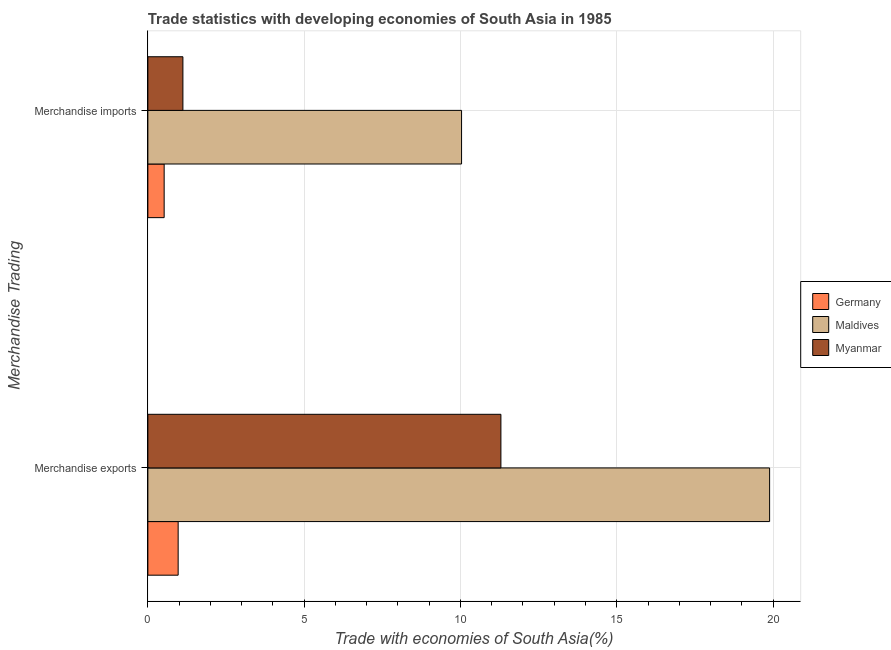How many different coloured bars are there?
Your response must be concise. 3. Are the number of bars per tick equal to the number of legend labels?
Offer a terse response. Yes. Are the number of bars on each tick of the Y-axis equal?
Provide a succinct answer. Yes. How many bars are there on the 1st tick from the top?
Give a very brief answer. 3. What is the merchandise exports in Myanmar?
Give a very brief answer. 11.29. Across all countries, what is the maximum merchandise exports?
Ensure brevity in your answer.  19.89. Across all countries, what is the minimum merchandise imports?
Provide a short and direct response. 0.52. In which country was the merchandise exports maximum?
Make the answer very short. Maldives. What is the total merchandise exports in the graph?
Ensure brevity in your answer.  32.15. What is the difference between the merchandise imports in Myanmar and that in Maldives?
Offer a very short reply. -8.91. What is the difference between the merchandise imports in Germany and the merchandise exports in Maldives?
Offer a terse response. -19.37. What is the average merchandise exports per country?
Offer a very short reply. 10.72. What is the difference between the merchandise exports and merchandise imports in Myanmar?
Your answer should be very brief. 10.17. What is the ratio of the merchandise exports in Germany to that in Maldives?
Keep it short and to the point. 0.05. What does the 1st bar from the top in Merchandise exports represents?
Offer a very short reply. Myanmar. What does the 3rd bar from the bottom in Merchandise imports represents?
Keep it short and to the point. Myanmar. How many bars are there?
Offer a terse response. 6. What is the difference between two consecutive major ticks on the X-axis?
Provide a succinct answer. 5. What is the title of the graph?
Ensure brevity in your answer.  Trade statistics with developing economies of South Asia in 1985. Does "St. Kitts and Nevis" appear as one of the legend labels in the graph?
Make the answer very short. No. What is the label or title of the X-axis?
Offer a terse response. Trade with economies of South Asia(%). What is the label or title of the Y-axis?
Offer a terse response. Merchandise Trading. What is the Trade with economies of South Asia(%) of Germany in Merchandise exports?
Make the answer very short. 0.97. What is the Trade with economies of South Asia(%) in Maldives in Merchandise exports?
Provide a succinct answer. 19.89. What is the Trade with economies of South Asia(%) of Myanmar in Merchandise exports?
Your response must be concise. 11.29. What is the Trade with economies of South Asia(%) of Germany in Merchandise imports?
Offer a very short reply. 0.52. What is the Trade with economies of South Asia(%) of Maldives in Merchandise imports?
Offer a terse response. 10.04. What is the Trade with economies of South Asia(%) in Myanmar in Merchandise imports?
Your response must be concise. 1.12. Across all Merchandise Trading, what is the maximum Trade with economies of South Asia(%) in Germany?
Provide a short and direct response. 0.97. Across all Merchandise Trading, what is the maximum Trade with economies of South Asia(%) in Maldives?
Your answer should be compact. 19.89. Across all Merchandise Trading, what is the maximum Trade with economies of South Asia(%) of Myanmar?
Keep it short and to the point. 11.29. Across all Merchandise Trading, what is the minimum Trade with economies of South Asia(%) in Germany?
Ensure brevity in your answer.  0.52. Across all Merchandise Trading, what is the minimum Trade with economies of South Asia(%) of Maldives?
Give a very brief answer. 10.04. Across all Merchandise Trading, what is the minimum Trade with economies of South Asia(%) of Myanmar?
Your answer should be compact. 1.12. What is the total Trade with economies of South Asia(%) of Germany in the graph?
Keep it short and to the point. 1.49. What is the total Trade with economies of South Asia(%) of Maldives in the graph?
Your answer should be compact. 29.93. What is the total Trade with economies of South Asia(%) in Myanmar in the graph?
Your answer should be very brief. 12.41. What is the difference between the Trade with economies of South Asia(%) in Germany in Merchandise exports and that in Merchandise imports?
Your answer should be compact. 0.45. What is the difference between the Trade with economies of South Asia(%) of Maldives in Merchandise exports and that in Merchandise imports?
Give a very brief answer. 9.85. What is the difference between the Trade with economies of South Asia(%) of Myanmar in Merchandise exports and that in Merchandise imports?
Provide a short and direct response. 10.17. What is the difference between the Trade with economies of South Asia(%) of Germany in Merchandise exports and the Trade with economies of South Asia(%) of Maldives in Merchandise imports?
Give a very brief answer. -9.07. What is the difference between the Trade with economies of South Asia(%) in Germany in Merchandise exports and the Trade with economies of South Asia(%) in Myanmar in Merchandise imports?
Make the answer very short. -0.15. What is the difference between the Trade with economies of South Asia(%) in Maldives in Merchandise exports and the Trade with economies of South Asia(%) in Myanmar in Merchandise imports?
Provide a short and direct response. 18.77. What is the average Trade with economies of South Asia(%) of Germany per Merchandise Trading?
Your answer should be compact. 0.74. What is the average Trade with economies of South Asia(%) of Maldives per Merchandise Trading?
Your response must be concise. 14.96. What is the average Trade with economies of South Asia(%) of Myanmar per Merchandise Trading?
Provide a succinct answer. 6.21. What is the difference between the Trade with economies of South Asia(%) in Germany and Trade with economies of South Asia(%) in Maldives in Merchandise exports?
Your answer should be very brief. -18.92. What is the difference between the Trade with economies of South Asia(%) of Germany and Trade with economies of South Asia(%) of Myanmar in Merchandise exports?
Offer a very short reply. -10.32. What is the difference between the Trade with economies of South Asia(%) in Maldives and Trade with economies of South Asia(%) in Myanmar in Merchandise exports?
Your answer should be compact. 8.6. What is the difference between the Trade with economies of South Asia(%) of Germany and Trade with economies of South Asia(%) of Maldives in Merchandise imports?
Offer a very short reply. -9.51. What is the difference between the Trade with economies of South Asia(%) in Germany and Trade with economies of South Asia(%) in Myanmar in Merchandise imports?
Your answer should be compact. -0.6. What is the difference between the Trade with economies of South Asia(%) in Maldives and Trade with economies of South Asia(%) in Myanmar in Merchandise imports?
Ensure brevity in your answer.  8.91. What is the ratio of the Trade with economies of South Asia(%) of Germany in Merchandise exports to that in Merchandise imports?
Make the answer very short. 1.86. What is the ratio of the Trade with economies of South Asia(%) in Maldives in Merchandise exports to that in Merchandise imports?
Give a very brief answer. 1.98. What is the ratio of the Trade with economies of South Asia(%) in Myanmar in Merchandise exports to that in Merchandise imports?
Your answer should be very brief. 10.07. What is the difference between the highest and the second highest Trade with economies of South Asia(%) of Germany?
Your response must be concise. 0.45. What is the difference between the highest and the second highest Trade with economies of South Asia(%) in Maldives?
Your answer should be very brief. 9.85. What is the difference between the highest and the second highest Trade with economies of South Asia(%) of Myanmar?
Offer a terse response. 10.17. What is the difference between the highest and the lowest Trade with economies of South Asia(%) of Germany?
Keep it short and to the point. 0.45. What is the difference between the highest and the lowest Trade with economies of South Asia(%) of Maldives?
Keep it short and to the point. 9.85. What is the difference between the highest and the lowest Trade with economies of South Asia(%) in Myanmar?
Your answer should be compact. 10.17. 